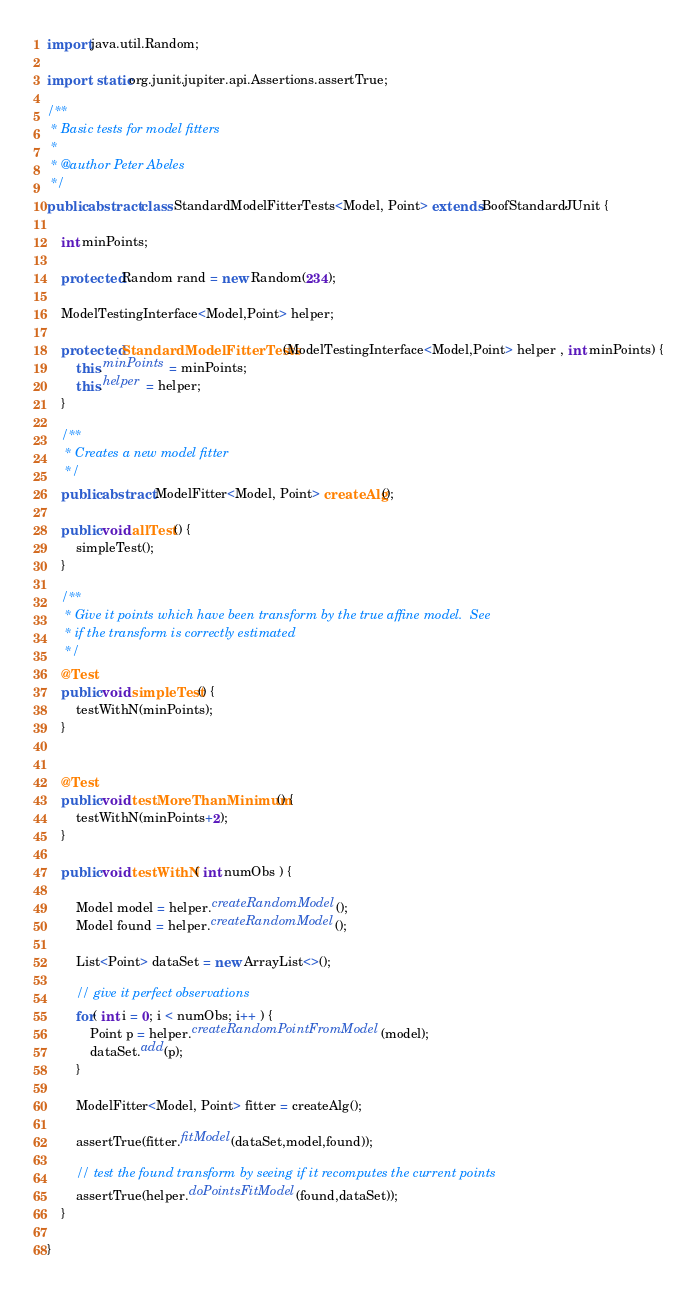Convert code to text. <code><loc_0><loc_0><loc_500><loc_500><_Java_>import java.util.Random;

import static org.junit.jupiter.api.Assertions.assertTrue;

/**
 * Basic tests for model fitters
 *
 * @author Peter Abeles
 */
public abstract class StandardModelFitterTests<Model, Point> extends BoofStandardJUnit {

	int minPoints;

	protected Random rand = new Random(234);

	ModelTestingInterface<Model,Point> helper;

	protected StandardModelFitterTests(ModelTestingInterface<Model,Point> helper , int minPoints) {
		this.minPoints = minPoints;
		this.helper = helper;
	}

	/**
	 * Creates a new model fitter
	 */
	public abstract ModelFitter<Model, Point> createAlg();

	public void allTest() {
		simpleTest();
	}

	/**
	 * Give it points which have been transform by the true affine model.  See
	 * if the transform is correctly estimated
	 */
	@Test
	public void simpleTest() {
		testWithN(minPoints);
	}


	@Test
	public void testMoreThanMinimum() {
		testWithN(minPoints+2);
	}

	public void testWithN( int numObs ) {

		Model model = helper.createRandomModel();
		Model found = helper.createRandomModel();

		List<Point> dataSet = new ArrayList<>();

		// give it perfect observations
		for( int i = 0; i < numObs; i++ ) {
			Point p = helper.createRandomPointFromModel(model);
			dataSet.add(p);
		}

		ModelFitter<Model, Point> fitter = createAlg();

		assertTrue(fitter.fitModel(dataSet,model,found));

		// test the found transform by seeing if it recomputes the current points
		assertTrue(helper.doPointsFitModel(found,dataSet));
	}

}
</code> 